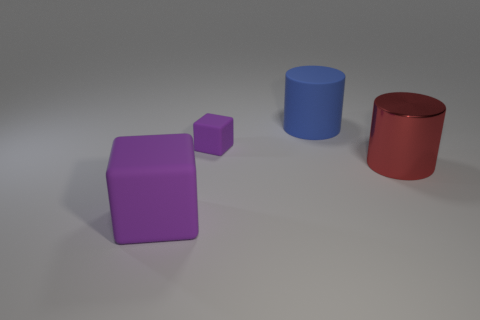Is there anything else that is made of the same material as the large red object?
Your response must be concise. No. There is a tiny purple matte object; is its shape the same as the large matte thing in front of the large matte cylinder?
Your answer should be very brief. Yes. What is the shape of the large object that is left of the red metallic thing and behind the big purple block?
Give a very brief answer. Cylinder. Are there an equal number of purple matte cubes to the right of the metallic thing and large red metallic things left of the small purple matte cube?
Keep it short and to the point. Yes. Do the big rubber object that is on the left side of the blue matte cylinder and the tiny purple rubber thing have the same shape?
Give a very brief answer. Yes. How many red things are large metal things or tiny things?
Offer a terse response. 1. What material is the other object that is the same shape as the blue object?
Give a very brief answer. Metal. What shape is the object that is behind the tiny block?
Offer a very short reply. Cylinder. Are there any big red cylinders made of the same material as the large cube?
Your response must be concise. No. What number of spheres are either large matte objects or big red metallic objects?
Provide a succinct answer. 0. 